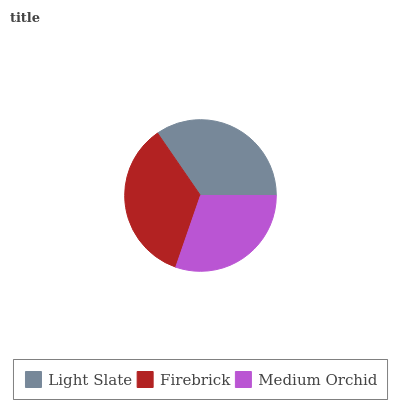Is Medium Orchid the minimum?
Answer yes or no. Yes. Is Firebrick the maximum?
Answer yes or no. Yes. Is Firebrick the minimum?
Answer yes or no. No. Is Medium Orchid the maximum?
Answer yes or no. No. Is Firebrick greater than Medium Orchid?
Answer yes or no. Yes. Is Medium Orchid less than Firebrick?
Answer yes or no. Yes. Is Medium Orchid greater than Firebrick?
Answer yes or no. No. Is Firebrick less than Medium Orchid?
Answer yes or no. No. Is Light Slate the high median?
Answer yes or no. Yes. Is Light Slate the low median?
Answer yes or no. Yes. Is Medium Orchid the high median?
Answer yes or no. No. Is Firebrick the low median?
Answer yes or no. No. 